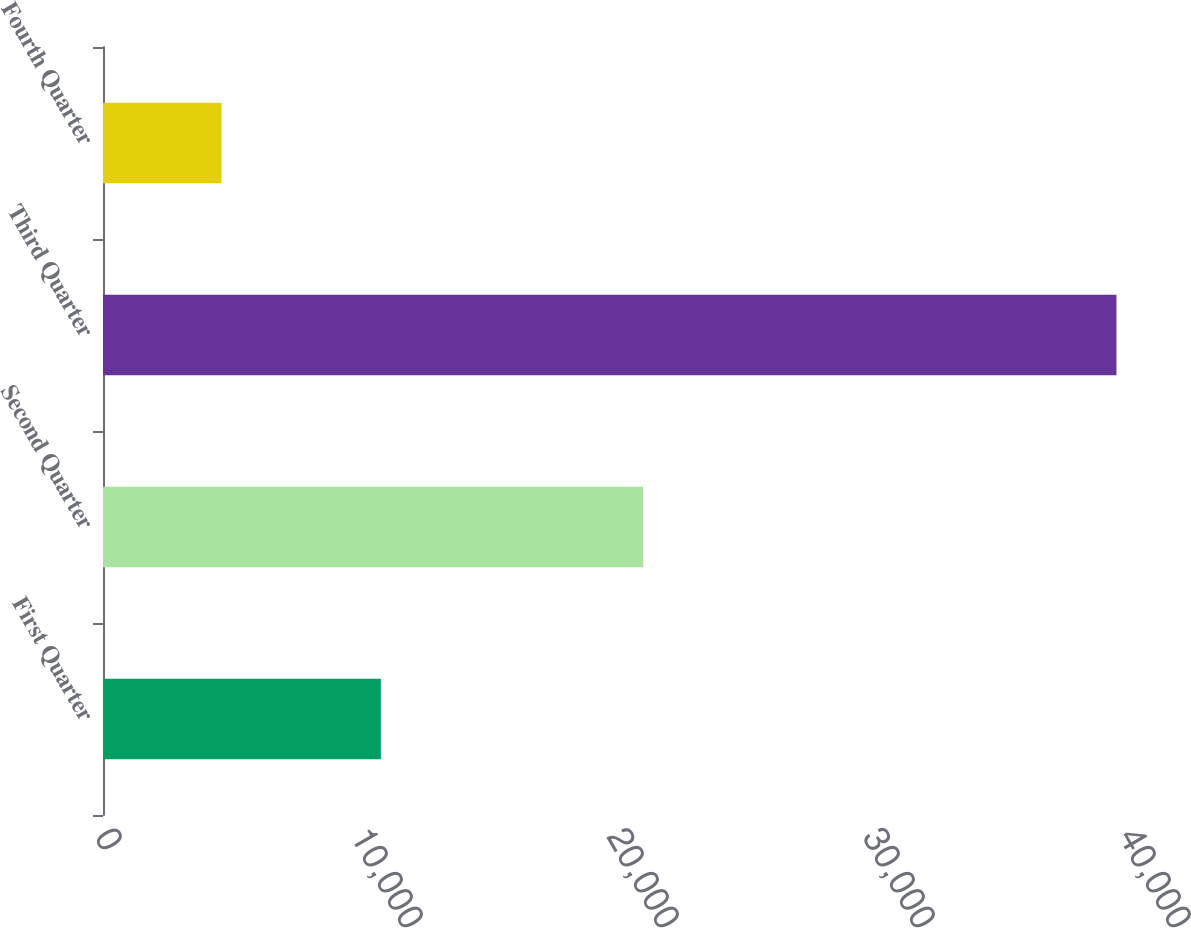<chart> <loc_0><loc_0><loc_500><loc_500><bar_chart><fcel>First Quarter<fcel>Second Quarter<fcel>Third Quarter<fcel>Fourth Quarter<nl><fcel>10854<fcel>21101<fcel>39588<fcel>4630<nl></chart> 